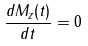<formula> <loc_0><loc_0><loc_500><loc_500>\frac { d M _ { z } ( t ) } { d t } = 0</formula> 